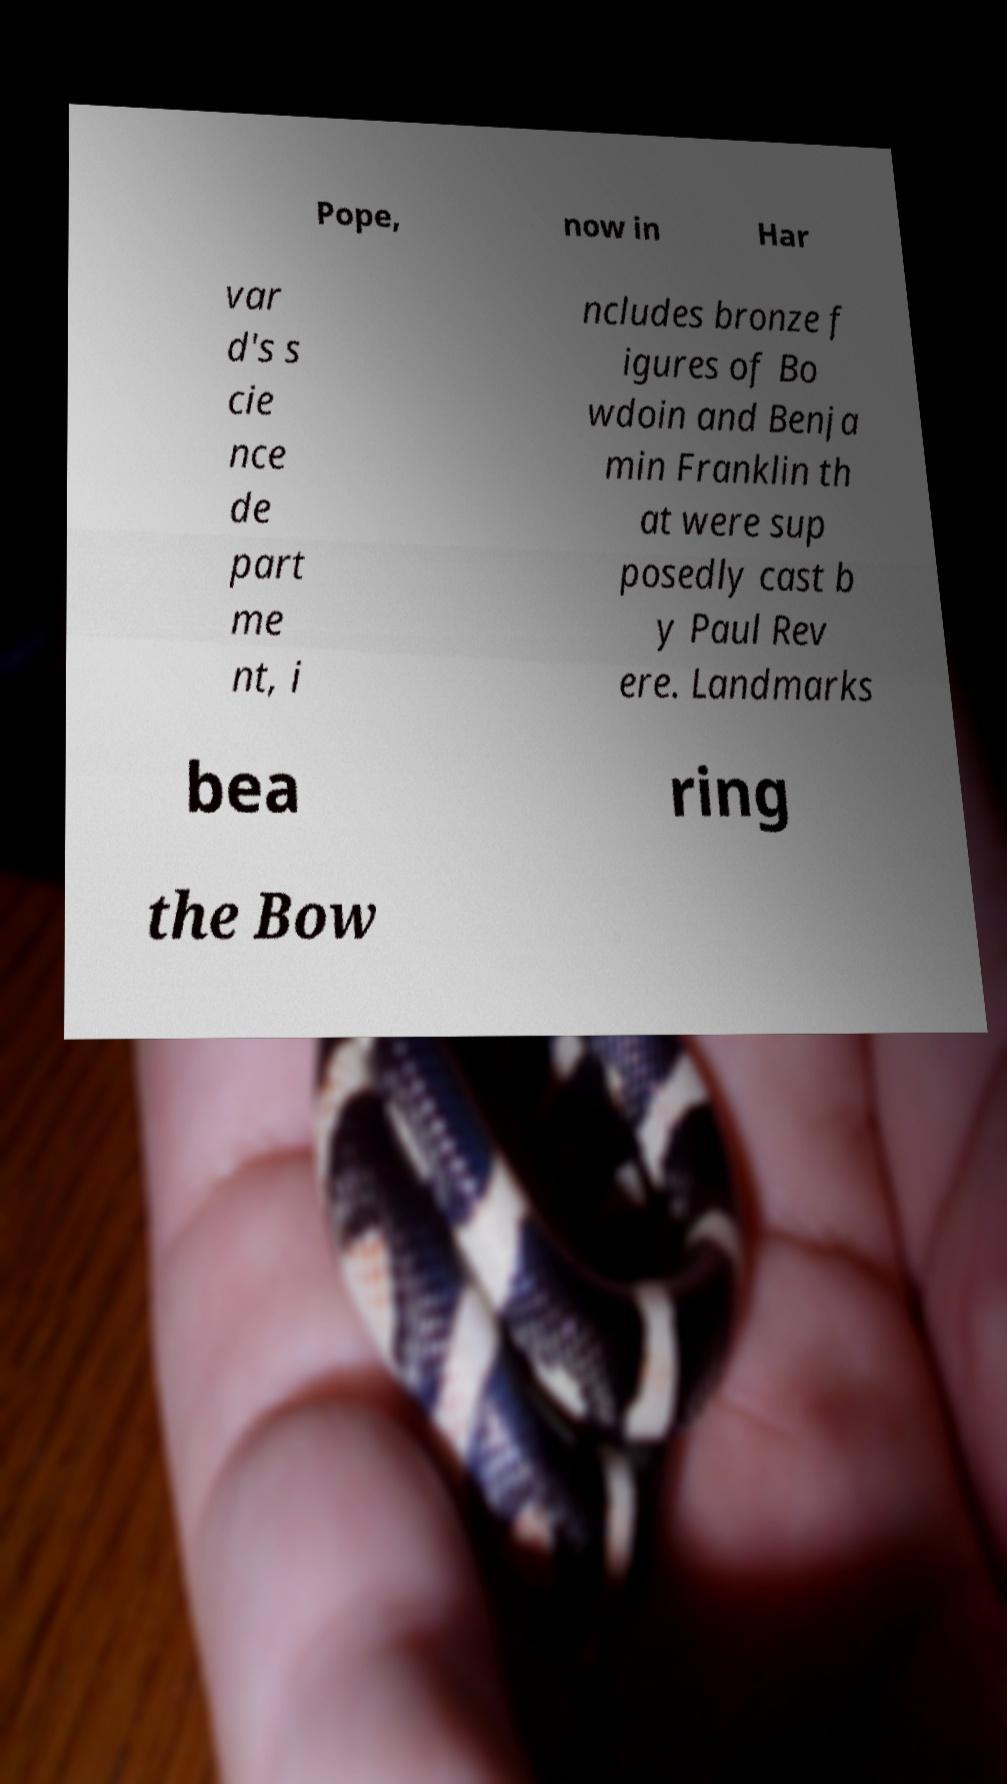Can you read and provide the text displayed in the image?This photo seems to have some interesting text. Can you extract and type it out for me? Pope, now in Har var d's s cie nce de part me nt, i ncludes bronze f igures of Bo wdoin and Benja min Franklin th at were sup posedly cast b y Paul Rev ere. Landmarks bea ring the Bow 